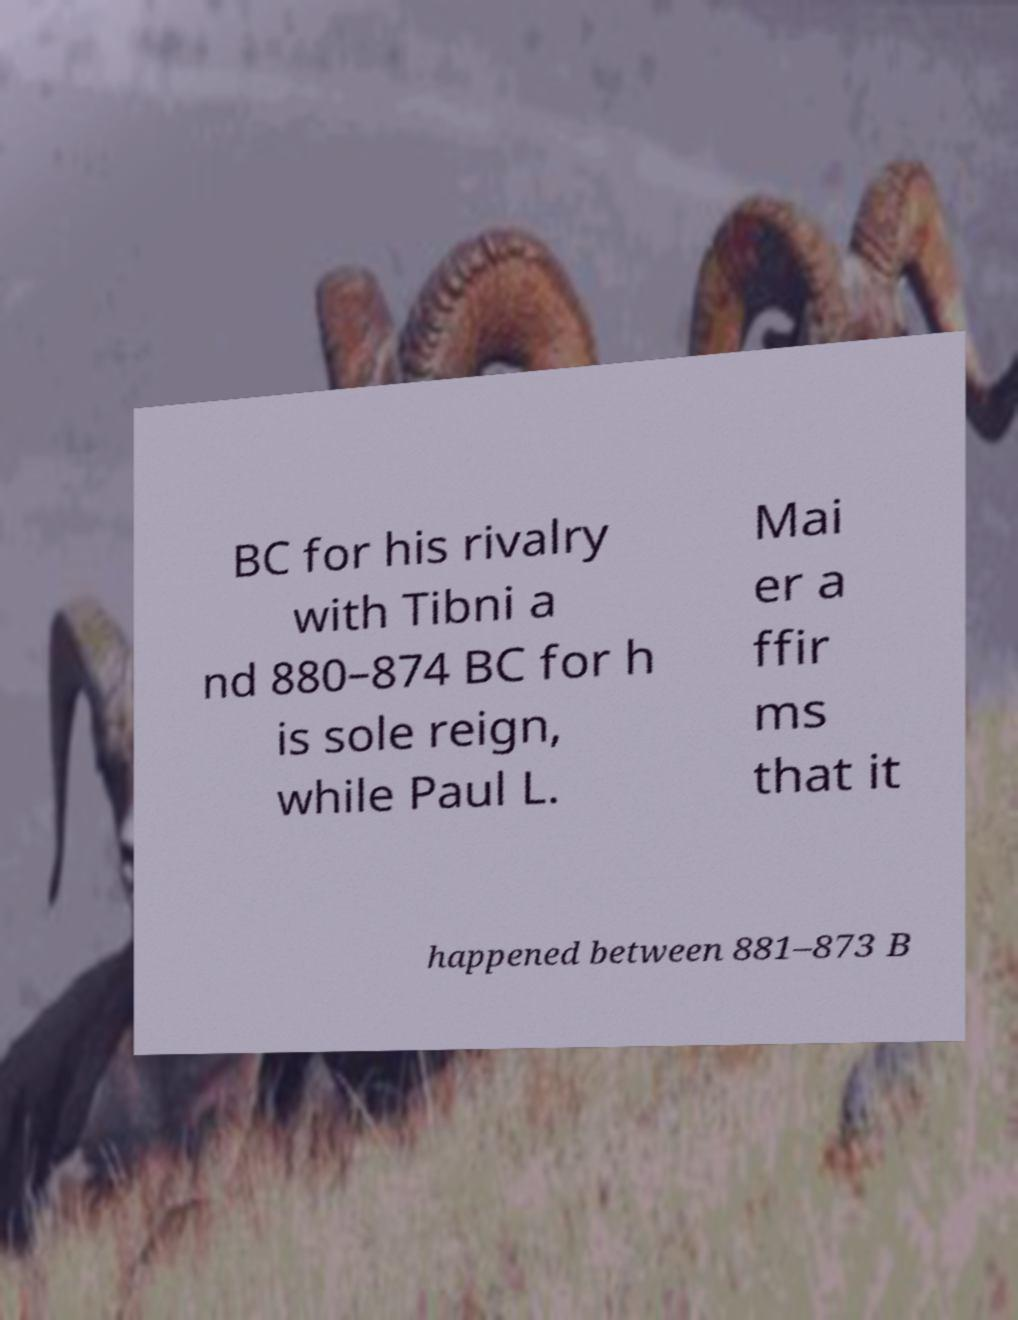Can you read and provide the text displayed in the image?This photo seems to have some interesting text. Can you extract and type it out for me? BC for his rivalry with Tibni a nd 880–874 BC for h is sole reign, while Paul L. Mai er a ffir ms that it happened between 881–873 B 